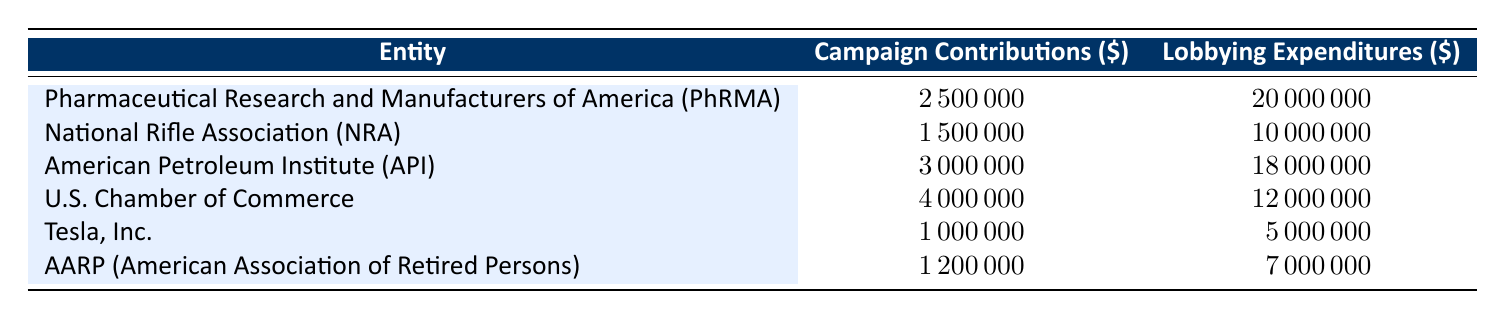What is the highest campaign contribution amount recorded in the table? Looking through the "Campaign Contributions" column, the highest value is 4000000, associated with the U.S. Chamber of Commerce.
Answer: 4000000 Which entity has the lowest lobbying expenditure? Examining the "Lobbying Expenditures" column, the lowest value is 5000000, linked to Tesla, Inc.
Answer: 5000000 What is the total campaign contribution from all entities listed? Summing all campaign contributions: 2500000 + 1500000 + 3000000 + 4000000 + 1000000 + 1200000 = 13900000.
Answer: 13900000 Is it true that the lobbying expenditures of PhRMA exceed its campaign contributions? Comparing values for PhRMA, campaign contributions are 2500000 and lobbying expenditures are 20000000. Since 20000000 is greater than 2500000, the statement is true.
Answer: Yes What is the average lobbying expenditure of the entities listed in the table? To find the average, first sum all lobbying expenditures: 20000000 + 10000000 + 18000000 + 12000000 + 5000000 + 7000000 = 73000000. There are 6 entities, so the average is 73000000 / 6 = 12166666.67.
Answer: 12166666.67 Which entity has the highest ratio of lobbying expenditures to campaign contributions? Calculate each ratio: PhRMA = 20000000/2500000 = 8, NRA = 10000000/1500000 = 6.67, API = 18000000/3000000 = 6, U.S. Chamber of Commerce = 12000000/4000000 = 3, Tesla = 5000000/1000000 = 5, AARP = 7000000/1200000 = 5.83. PhRMA has the highest ratio of 8.
Answer: PhRMA What is the total lobbying expenditure for all entities? Summing all lobbying expenditures gives us: 20000000 + 10000000 + 18000000 + 12000000 + 5000000 + 7000000 = 73000000.
Answer: 73000000 Did any entity spend more on lobbying than they contributed in campaign contributions? Yes, comparing each entity, PhRMA, NRA, API, and U.S. Chamber of Commerce each spent more on lobbying than they contributed to campaigns.
Answer: Yes 